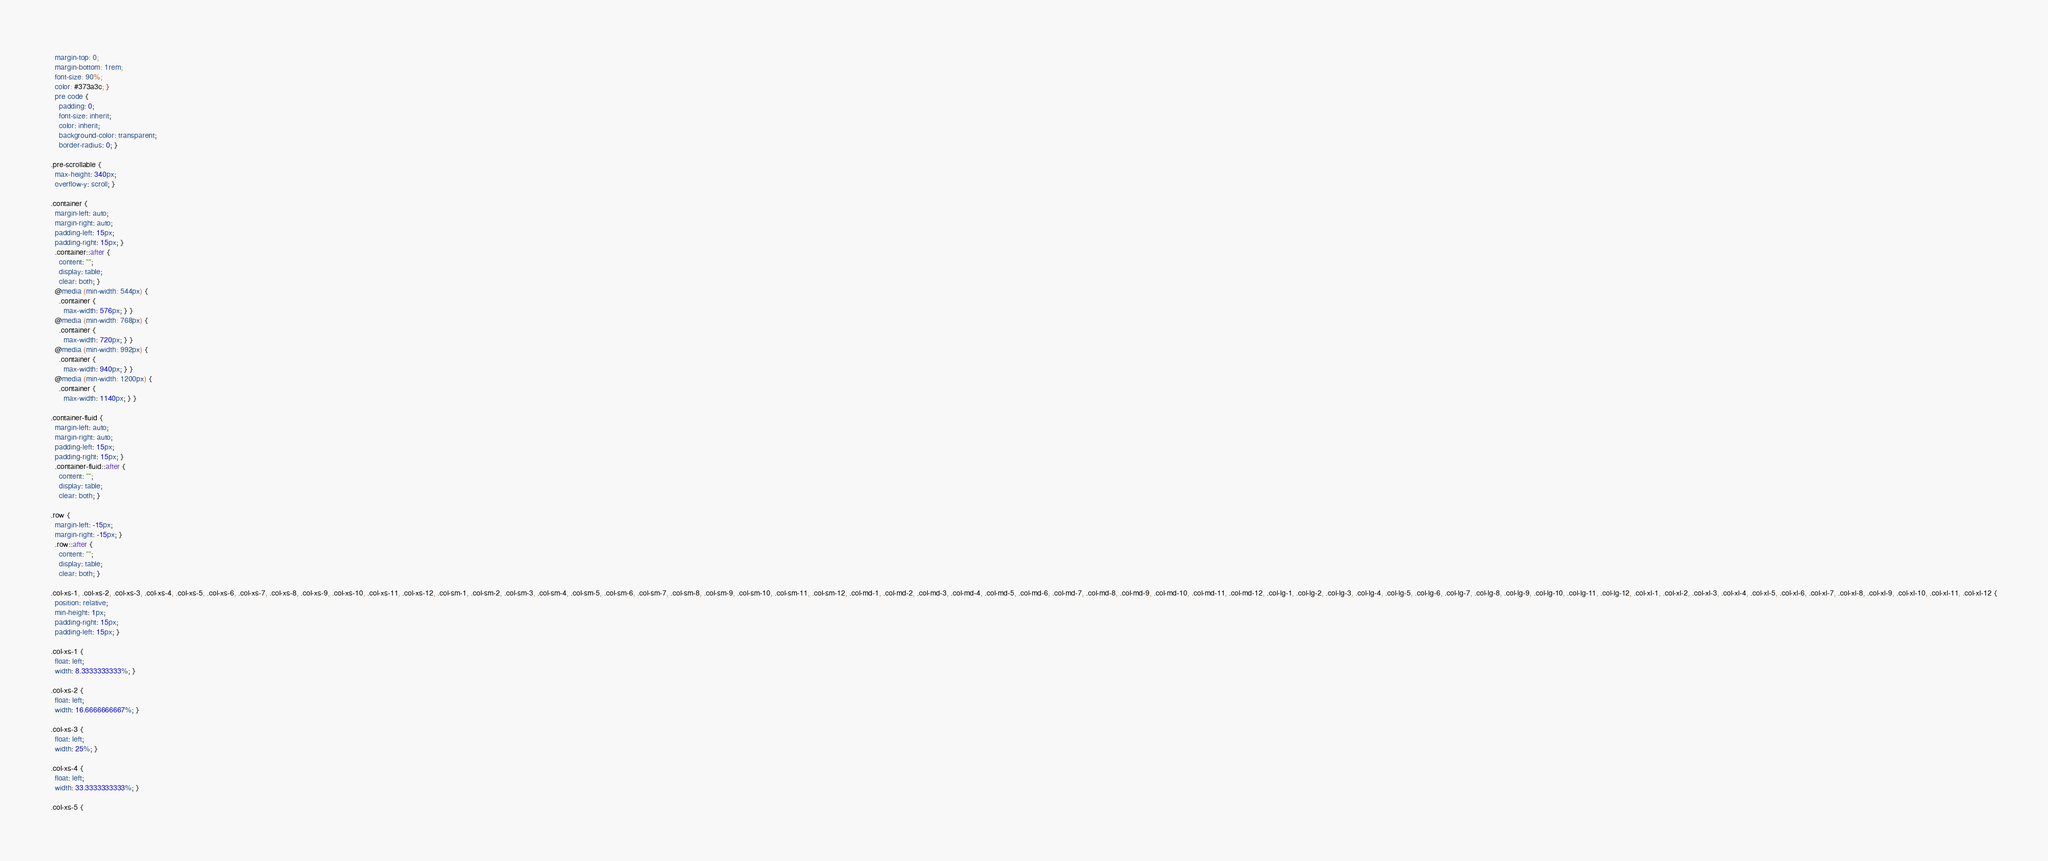Convert code to text. <code><loc_0><loc_0><loc_500><loc_500><_CSS_>  margin-top: 0;
  margin-bottom: 1rem;
  font-size: 90%;
  color: #373a3c; }
  pre code {
    padding: 0;
    font-size: inherit;
    color: inherit;
    background-color: transparent;
    border-radius: 0; }

.pre-scrollable {
  max-height: 340px;
  overflow-y: scroll; }

.container {
  margin-left: auto;
  margin-right: auto;
  padding-left: 15px;
  padding-right: 15px; }
  .container::after {
    content: "";
    display: table;
    clear: both; }
  @media (min-width: 544px) {
    .container {
      max-width: 576px; } }
  @media (min-width: 768px) {
    .container {
      max-width: 720px; } }
  @media (min-width: 992px) {
    .container {
      max-width: 940px; } }
  @media (min-width: 1200px) {
    .container {
      max-width: 1140px; } }

.container-fluid {
  margin-left: auto;
  margin-right: auto;
  padding-left: 15px;
  padding-right: 15px; }
  .container-fluid::after {
    content: "";
    display: table;
    clear: both; }

.row {
  margin-left: -15px;
  margin-right: -15px; }
  .row::after {
    content: "";
    display: table;
    clear: both; }

.col-xs-1, .col-xs-2, .col-xs-3, .col-xs-4, .col-xs-5, .col-xs-6, .col-xs-7, .col-xs-8, .col-xs-9, .col-xs-10, .col-xs-11, .col-xs-12, .col-sm-1, .col-sm-2, .col-sm-3, .col-sm-4, .col-sm-5, .col-sm-6, .col-sm-7, .col-sm-8, .col-sm-9, .col-sm-10, .col-sm-11, .col-sm-12, .col-md-1, .col-md-2, .col-md-3, .col-md-4, .col-md-5, .col-md-6, .col-md-7, .col-md-8, .col-md-9, .col-md-10, .col-md-11, .col-md-12, .col-lg-1, .col-lg-2, .col-lg-3, .col-lg-4, .col-lg-5, .col-lg-6, .col-lg-7, .col-lg-8, .col-lg-9, .col-lg-10, .col-lg-11, .col-lg-12, .col-xl-1, .col-xl-2, .col-xl-3, .col-xl-4, .col-xl-5, .col-xl-6, .col-xl-7, .col-xl-8, .col-xl-9, .col-xl-10, .col-xl-11, .col-xl-12 {
  position: relative;
  min-height: 1px;
  padding-right: 15px;
  padding-left: 15px; }

.col-xs-1 {
  float: left;
  width: 8.3333333333%; }

.col-xs-2 {
  float: left;
  width: 16.6666666667%; }

.col-xs-3 {
  float: left;
  width: 25%; }

.col-xs-4 {
  float: left;
  width: 33.3333333333%; }

.col-xs-5 {</code> 